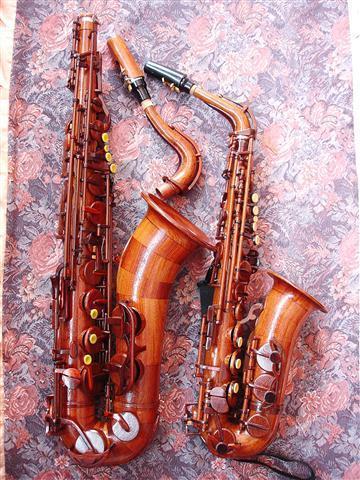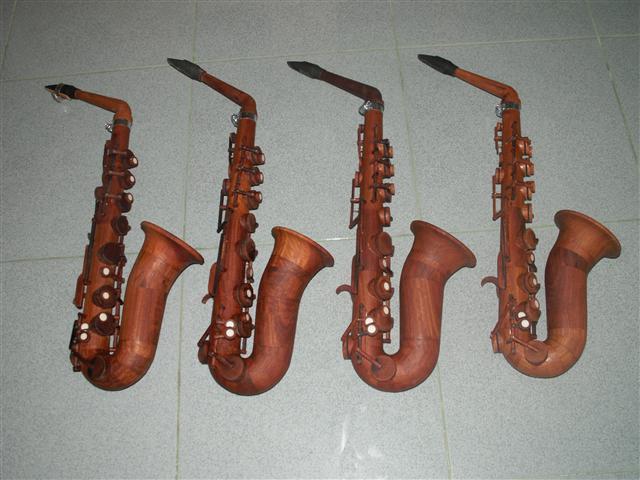The first image is the image on the left, the second image is the image on the right. Considering the images on both sides, is "There are at least four instruments in total shown." valid? Answer yes or no. Yes. 